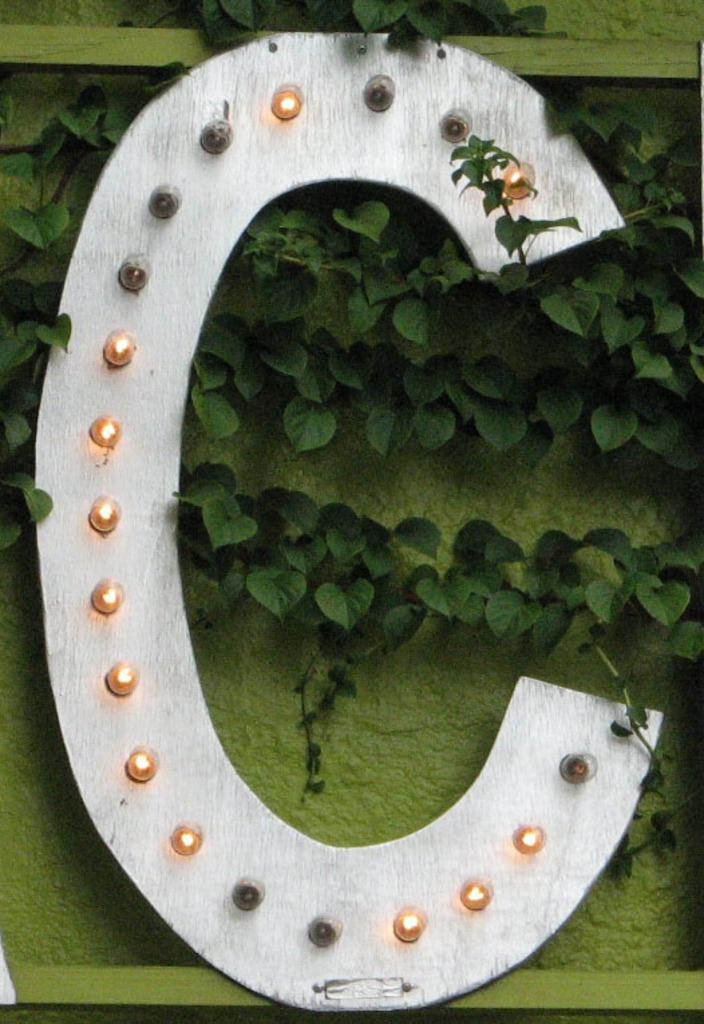What type of structure can be seen in the image? There is a wall in the image. What natural elements are visible in the image? Leaves are present in the image. Are there any artificial light sources in the image? Yes, there are lights in the image. Can you see a lake in the image? No, there is no lake present in the image. 